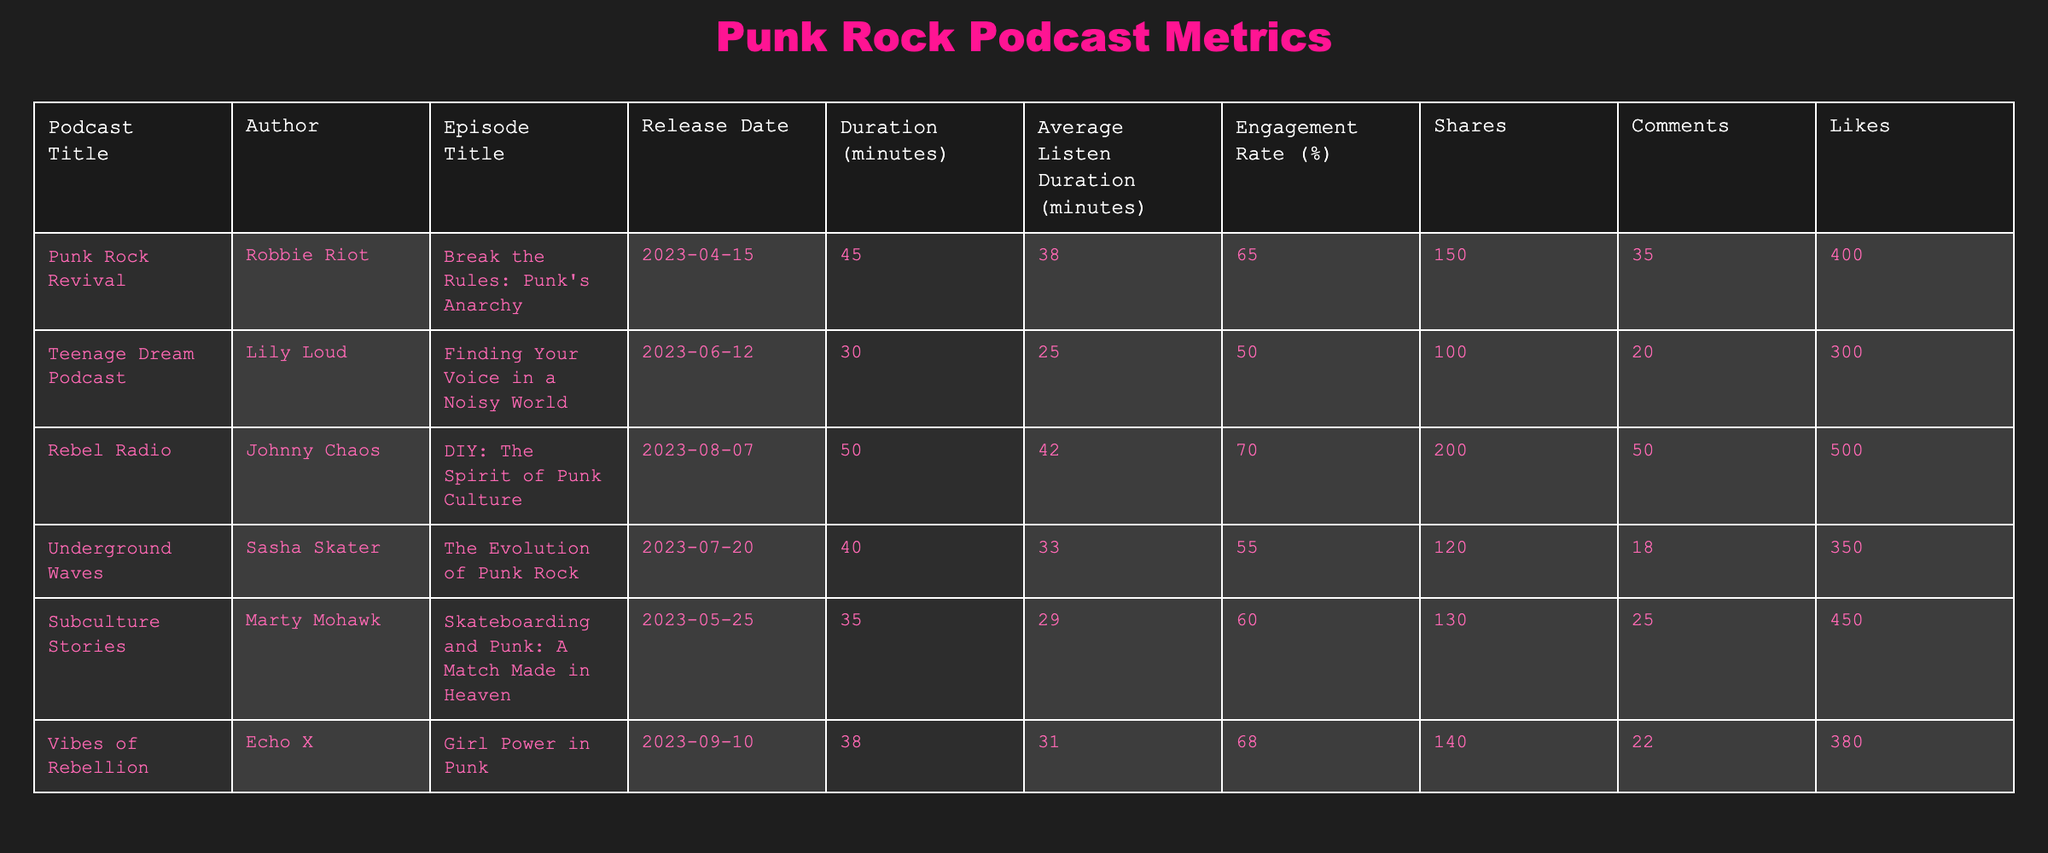What is the average listen duration for episodes with an engagement rate above 60%? The episodes with an engagement rate above 60% are "Break the Rules: Punk's Anarchy," "DIY: The Spirit of Punk Culture," and "Girl Power in Punk." Their average listen durations are 38, 42, and 31 minutes respectively. Summing these gives 38 + 42 + 31 = 111 minutes. Dividing by the 3 episodes gives an average of 111/3 = 37 minutes.
Answer: 37 minutes Which podcast episode received the most likes? Checking the "Likes" column, the episode "DIY: The Spirit of Punk Culture" received 500 likes, which is more than any other episode.
Answer: "DIY: The Spirit of Punk Culture" How many episodes have a duration of more than 40 minutes? The episodes with a duration greater than 40 minutes are "Break the Rules: Punk's Anarchy" (45 minutes), "DIY: The Spirit of Punk Culture" (50 minutes), and "The Evolution of Punk Rock" (40 minutes). This gives a total of 3 episodes.
Answer: 3 episodes Did the podcast "Teenage Dream Podcast" have an average listen duration greater than 25 minutes? The average listen duration for "Finding Your Voice in a Noisy World" is 25 minutes, which is not greater. Therefore, the answer is no.
Answer: No What is the total number of shares across all episodes? To find the total number of shares, we add the shares of all episodes: 150 + 100 + 200 + 120 + 130 + 140 = 940 shares in total.
Answer: 940 shares Which episode had the lowest engagement rate? The lowest engagement rate is from "Finding Your Voice in a Noisy World," which had a rate of 50%.
Answer: "Finding Your Voice in a Noisy World" Is the engagement rate of "Skateboarding and Punk: A Match Made in Heaven" greater than 60%? The engagement rate for this episode is 60%, thus it is not greater than 60%.
Answer: No What is the difference in average listen duration between the highest and lowest engagement rates? The highest engagement rate is 70% (from "DIY: The Spirit of Punk Culture" with an average listen duration of 42 minutes), and the lowest engagement rate is 50% (from "Finding Your Voice in a Noisy World" with an average listen duration of 25 minutes). The difference in average listen duration is 42 - 25 = 17 minutes.
Answer: 17 minutes 